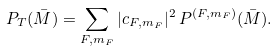<formula> <loc_0><loc_0><loc_500><loc_500>P _ { T } ( \bar { M } ) = \sum _ { F , m _ { F } } | c _ { F , m _ { F } } | ^ { 2 } \, P ^ { ( F , m _ { F } ) } ( \bar { M } ) .</formula> 